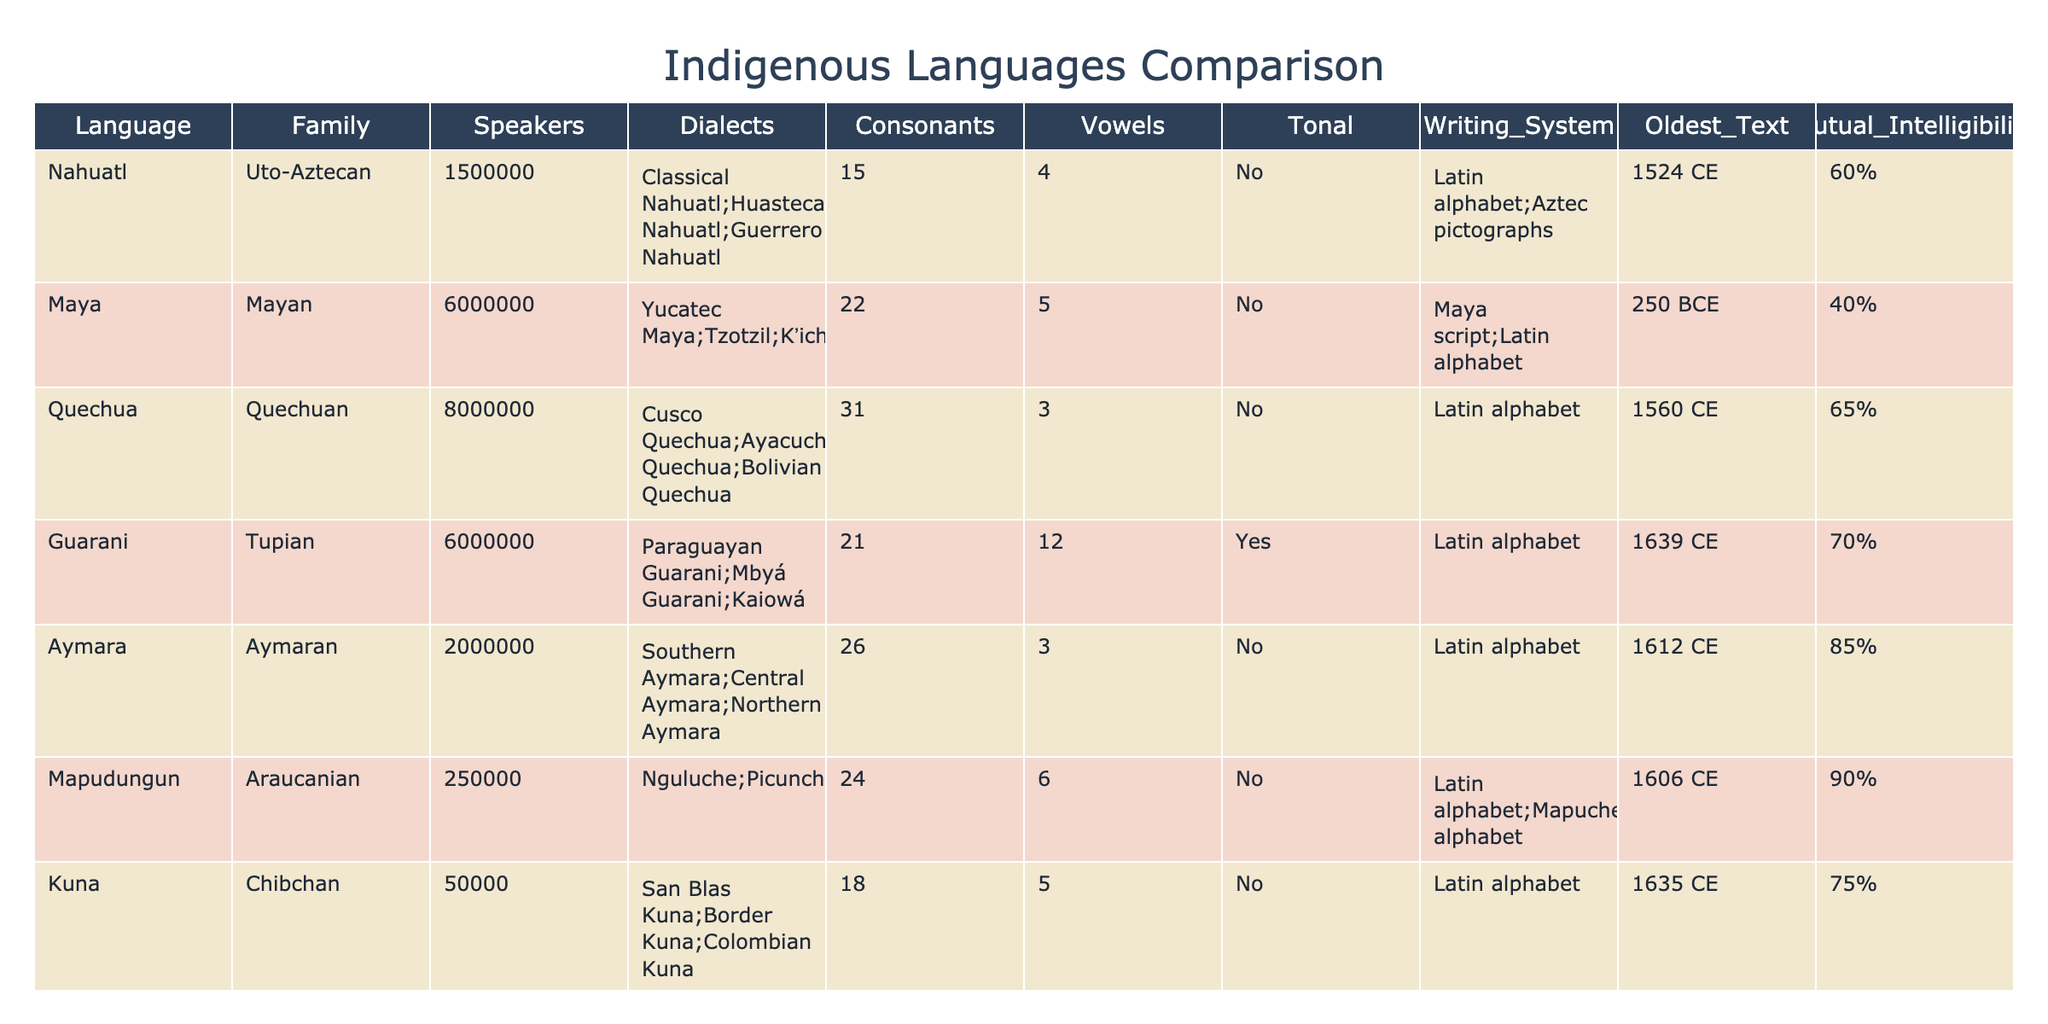What is the family of the Quechua language? The table lists Quechua under the "Family" column, which shows it belongs to the Quechuan family.
Answer: Quechuan How many speakers does the Guarani language have? Referring to the "Speakers" column for Guarani shows the value of 6,000,000.
Answer: 6,000,000 Which language has the highest mutual intelligibility percentage? The "Mutual Intelligibility" column shows that Aymara has the highest percentage with 85%.
Answer: 85% What is the writing system used for Nahuatl? The "Writing_System" column for Nahuatl indicates it uses a Latin alphabet and Aztec pictographs.
Answer: Latin alphabet; Aztec pictographs What is the average number of vowels across the languages? The total number of vowels is 4 (Nahuatl) + 5 (Maya) + 3 (Quechua) + 12 (Guarani) + 3 (Aymara) + 6 (Mapudungun) + 5 (Kuna) + 5 (Mixtec) + 6 (Wayuu) + 5 (Tzeltal) = 54. There are 10 languages, so the average is 54/10 = 5.4.
Answer: 5.4 Which language has the oldest text? The "Oldest_Text" column shows that the Maya language has the oldest text dated at 250 BCE, which is earlier than all other entries.
Answer: Maya Do all languages in the table have a tonal nature? Checking the "Tonal" column, we see that Guarani is the only language categorized as "Yes," while all others are "No."
Answer: No How many languages are associated with the Uto-Aztecan family? By inspecting the "Family" column, only Nahuatl is listed under Uto-Aztecan, hence there is one language in this family.
Answer: 1 Which language has the most consonants? The highest count in the "Consonants" column is 31 for Quechua, indicating it has the most consonants among the listed languages.
Answer: Quechua If you combine the number of speakers of Aymara and Mapudungun, how many speakers would there be? Summing the "Speakers" values, Aymara has 2,000,000 and Mapudungun has 250,000, leading to a total of 2,000,000 + 250,000 = 2,250,000 speakers combined.
Answer: 2,250,000 